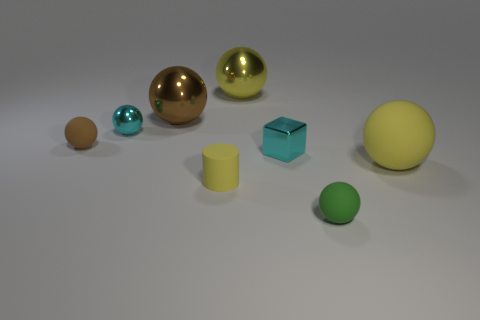Do the tiny cylinder and the large ball on the right side of the yellow metallic ball have the same color?
Give a very brief answer. Yes. What material is the tiny thing that is the same color as the small cube?
Offer a terse response. Metal. There is a small metallic thing that is the same shape as the brown rubber object; what color is it?
Give a very brief answer. Cyan. Is there a sphere that has the same color as the tiny cylinder?
Provide a short and direct response. Yes. What color is the matte object that is behind the tiny cylinder and on the left side of the cyan cube?
Make the answer very short. Brown. How big is the green thing?
Offer a very short reply. Small. What number of yellow metal objects have the same size as the green matte sphere?
Ensure brevity in your answer.  0. Are the tiny cyan thing to the left of the tiny yellow thing and the big sphere to the left of the cylinder made of the same material?
Make the answer very short. Yes. What is the material of the yellow ball that is on the left side of the tiny sphere right of the big yellow metallic sphere?
Your answer should be very brief. Metal. There is a large ball that is to the right of the green ball; what is its material?
Offer a terse response. Rubber. 